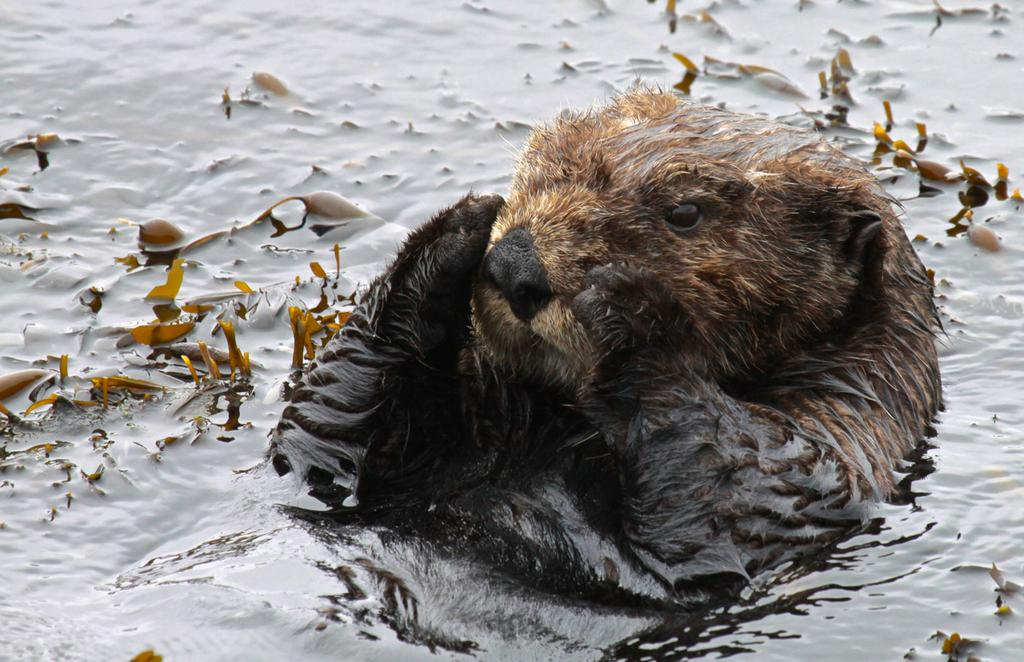What type of animal is in the image? There is a sea otter in the image. Where is the sea otter located? The sea otter is in the water. How many houses can be seen in the image? There are no houses present in the image; it features a sea otter in the water. What type of play is the sea otter engaged in within the image? There is no indication of play in the image; the sea otter is simply in the water. 